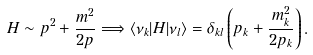<formula> <loc_0><loc_0><loc_500><loc_500>H \sim p ^ { 2 } + \frac { m ^ { 2 } } { 2 p } \Longrightarrow \langle \nu _ { k } | H | \nu _ { l } \rangle = \delta _ { k l } \left ( p _ { k } + \frac { m _ { k } ^ { 2 } } { 2 p _ { k } } \right ) .</formula> 